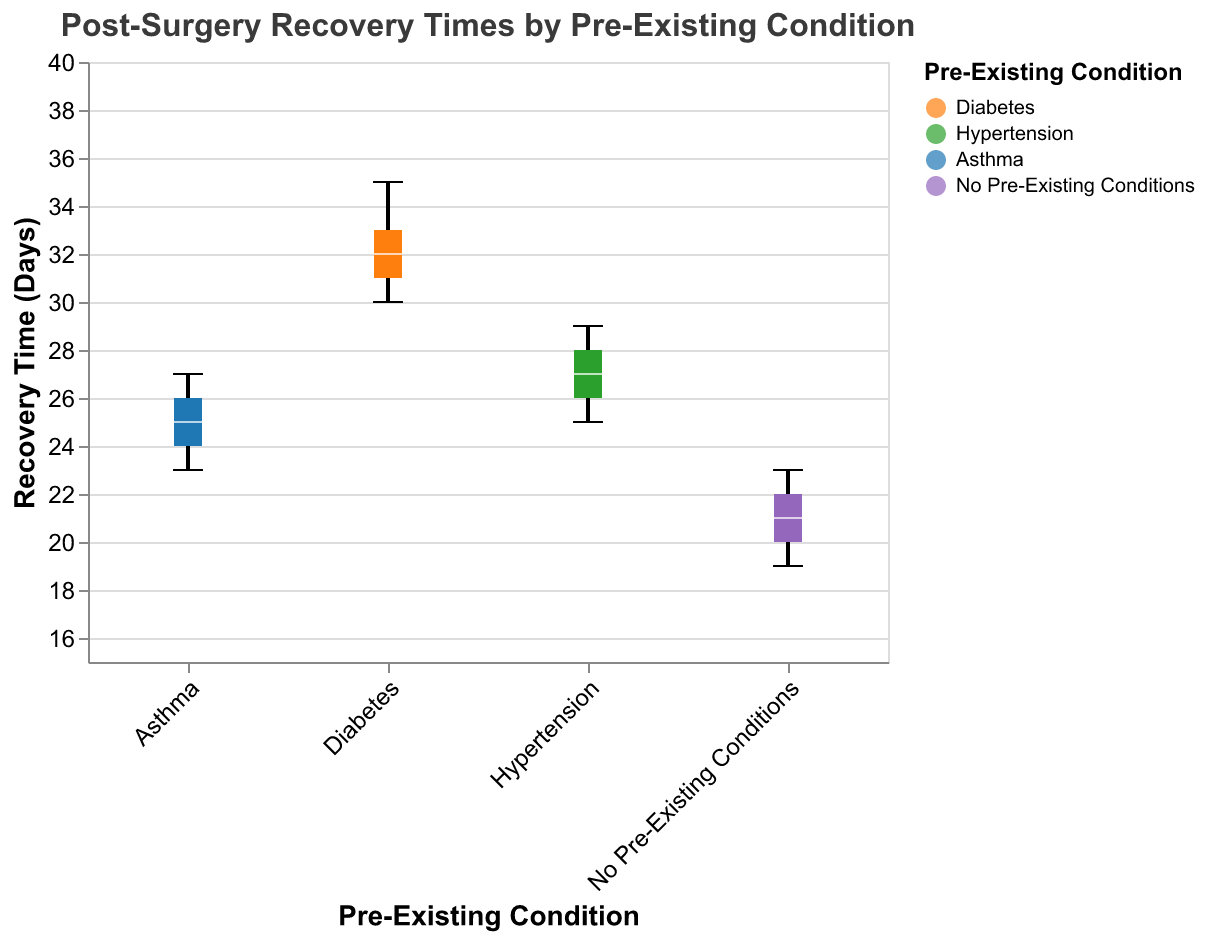What is the median recovery time for patients with Diabetes? Identify the "Diabetes" category and locate the median marker (line inside the box).
Answer: 32 days How does the maximum recovery time for Asthma compare to the maximum for Hypertension? Find the highest (top whisker) points for both Asthma and Hypertension and compare them.
Answer: Asthma's maximum is higher Which pre-existing condition group has the shortest median recovery time? Check the median markers (lines inside the boxes) for all groups and identify the shortest one.
Answer: No Pre-Existing Conditions What is the difference in the median recovery times between patients with Hypertension and No Pre-Existing Conditions? Locate the medians for both Hypertension and No Pre-Existing Conditions and subtract the smaller from the larger.
Answer: 6 days What is the range of recovery times for patients with Diabetes? Identify the top and bottom whiskers for Diabetes and subtract the lower value from the higher one.
Answer: 5 days How many pre-existing condition groups are compared in the plot? Count the distinct categories on the x-axis.
Answer: 4 Which group has the widest range in recovery times? Evaluate the length of the whiskers for each group to determine the widest range.
Answer: Diabetes Is there any group where the minimum recovery time is below 20 days? Locate the bottom whiskers for all groups and check if any are below 20 days.
Answer: Yes, No Pre-Existing Conditions What is the interquartile range (IQR) for patients with Asthma? Identify the upper and lower ends of the box for Asthma and subtract the lower value from the upper value.
Answer: 3 days Which group has the least variation in recovery times? Compare the lengths of the boxes for all groups to find the smallest one.
Answer: Hypertension 